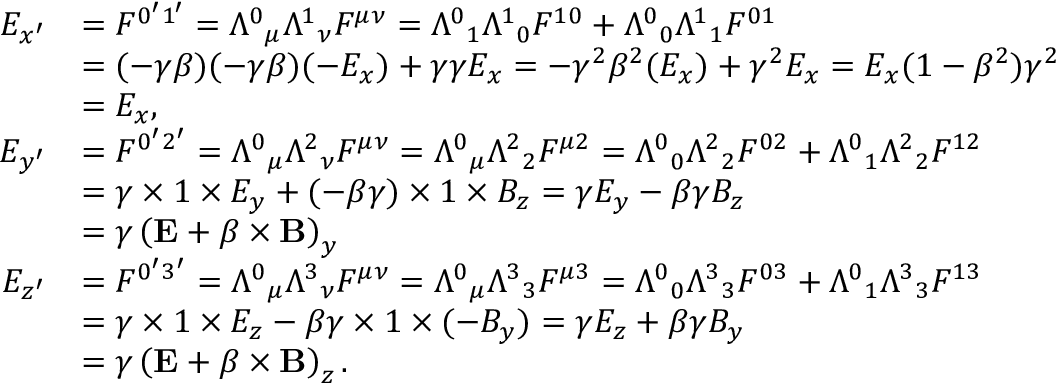<formula> <loc_0><loc_0><loc_500><loc_500>{ \begin{array} { r l } { E _ { x ^ { \prime } } } & { = F ^ { 0 ^ { \prime } 1 ^ { \prime } } = { \Lambda ^ { 0 } } _ { \mu } { \Lambda ^ { 1 } } _ { \nu } F ^ { \mu \nu } = { \Lambda ^ { 0 } } _ { 1 } { \Lambda ^ { 1 } } _ { 0 } F ^ { 1 0 } + { \Lambda ^ { 0 } } _ { 0 } { \Lambda ^ { 1 } } _ { 1 } F ^ { 0 1 } } \\ & { = ( - \gamma \beta ) ( - \gamma \beta ) ( - E _ { x } ) + \gamma \gamma E _ { x } = - \gamma ^ { 2 } \beta ^ { 2 } ( E _ { x } ) + \gamma ^ { 2 } E _ { x } = E _ { x } ( 1 - \beta ^ { 2 } ) \gamma ^ { 2 } } \\ & { = E _ { x } , } \\ { E _ { y ^ { \prime } } } & { = F ^ { 0 ^ { \prime } 2 ^ { \prime } } = { \Lambda ^ { 0 } } _ { \mu } { \Lambda ^ { 2 } } _ { \nu } F ^ { \mu \nu } = { \Lambda ^ { 0 } } _ { \mu } { \Lambda ^ { 2 } } _ { 2 } F ^ { \mu 2 } = { \Lambda ^ { 0 } } _ { 0 } { \Lambda ^ { 2 } } _ { 2 } F ^ { 0 2 } + { \Lambda ^ { 0 } } _ { 1 } { \Lambda ^ { 2 } } _ { 2 } F ^ { 1 2 } } \\ & { = \gamma \times 1 \times E _ { y } + ( - \beta \gamma ) \times 1 \times B _ { z } = \gamma E _ { y } - \beta \gamma B _ { z } } \\ & { = \gamma \left ( E + { \beta } \times B \right ) _ { y } } \\ { E _ { z ^ { \prime } } } & { = F ^ { 0 ^ { \prime } 3 ^ { \prime } } = { \Lambda ^ { 0 } } _ { \mu } { \Lambda ^ { 3 } } _ { \nu } F ^ { \mu \nu } = { \Lambda ^ { 0 } } _ { \mu } { \Lambda ^ { 3 } } _ { 3 } F ^ { \mu 3 } = { \Lambda ^ { 0 } } _ { 0 } { \Lambda ^ { 3 } } _ { 3 } F ^ { 0 3 } + { \Lambda ^ { 0 } } _ { 1 } { \Lambda ^ { 3 } } _ { 3 } F ^ { 1 3 } } \\ & { = \gamma \times 1 \times E _ { z } - \beta \gamma \times 1 \times ( - B _ { y } ) = \gamma E _ { z } + \beta \gamma B _ { y } } \\ & { = \gamma \left ( E + { \beta } \times B \right ) _ { z } . } \end{array} }</formula> 